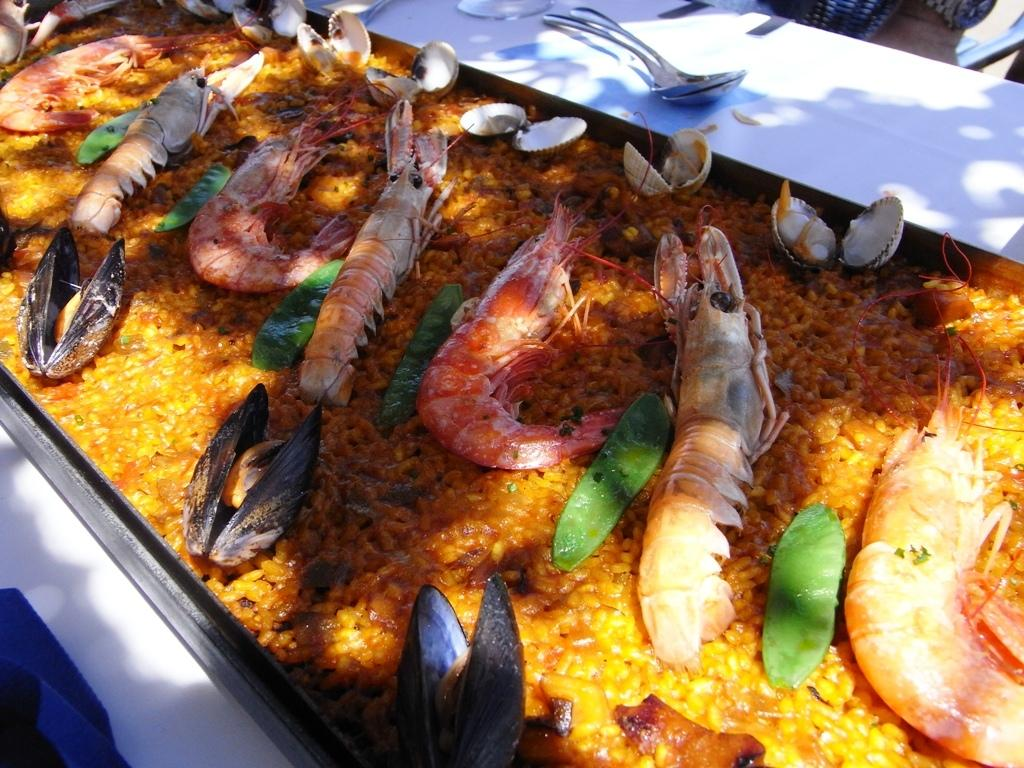What type of food item is in the container in the image? The specific type of food item in the container is not mentioned in the facts, so we cannot determine it. What objects are on the white surface in the image? The facts mention that there are objects like spoons on a white surface in the image. Can you describe the container holding the food item? The facts only mention that there is a container holding the food item, but no specific details about the container are provided. How many grapes are visible on the chin of the person in the image? There is no person or grapes mentioned in the image, so we cannot determine the presence of grapes on a chin. 